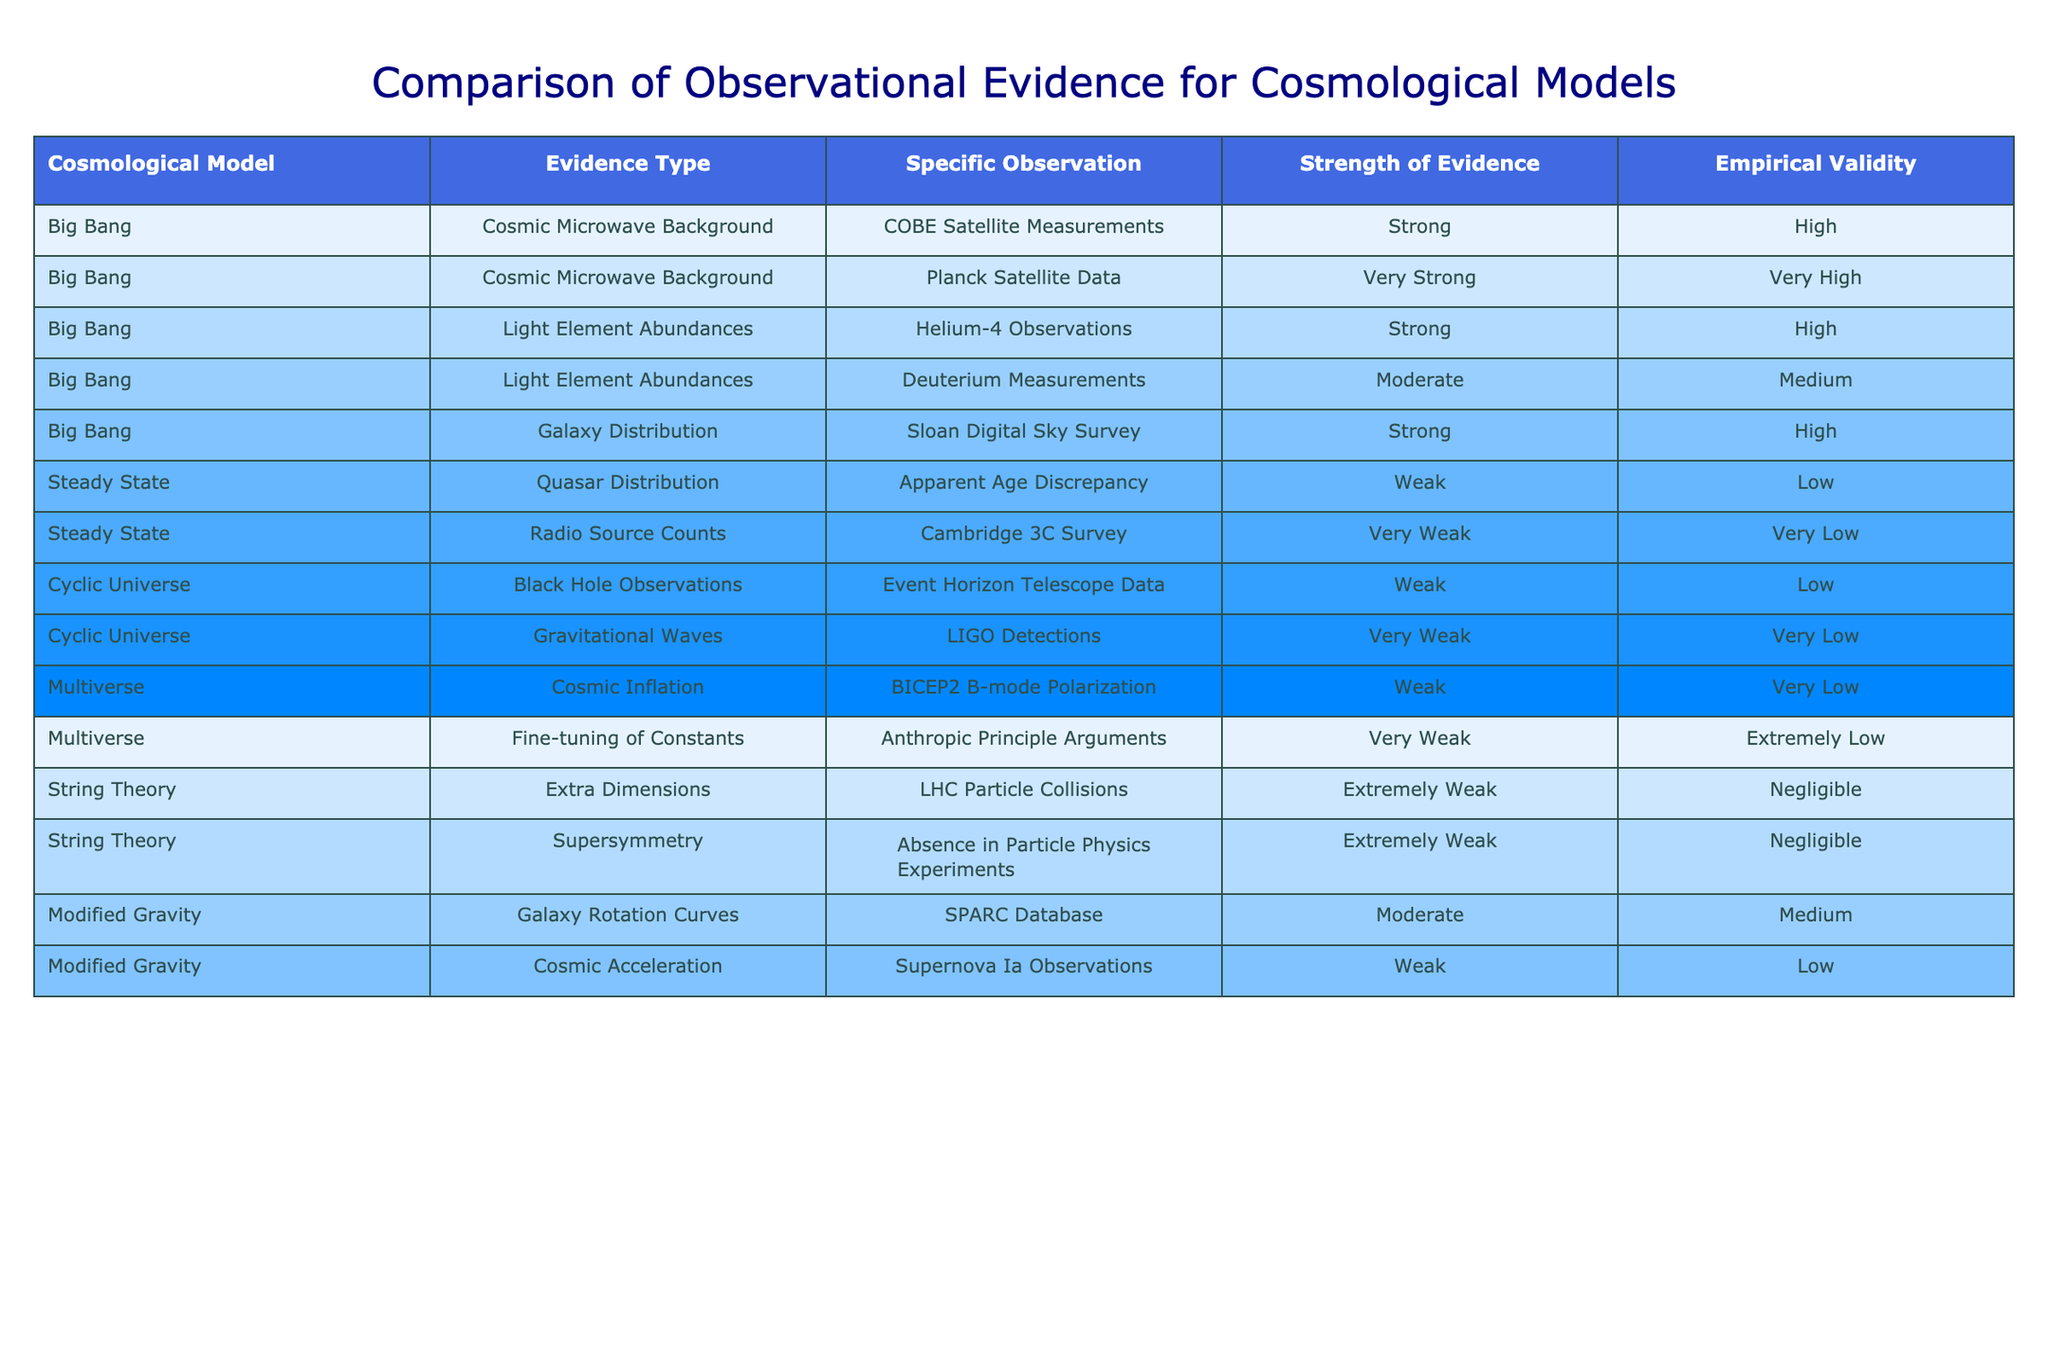What is the strength of evidence for the Planck Satellite Data? In the table, the strength of evidence for the Planck Satellite Data, which falls under the Cosmic Microwave Background type for the Big Bang model, is labeled as "Very Strong."
Answer: Very Strong Which cosmological model has the highest empirical validity? The table indicates that the Big Bang model has the highest empirical validity rating, marked as "Very High."
Answer: Very High How many types of observational evidence are listed for the Big Bang model? The Big Bang model has three types of observational evidence listed: Cosmic Microwave Background, Light Element Abundances, and Galaxy Distribution, totaling three types.
Answer: 3 What is the strength of the evidence for the understanding of Supernova Ia Observations in relation to the Modified Gravity model? The evidence strength related to Supernova Ia Observations in the Modified Gravity model is categorized as "Weak" in the table.
Answer: Weak Is there any observational evidence for the String Theory model that has a high empirical validity? The table shows that all observational evidence for the String Theory model has an empirical validity rated as "Negligible," indicating none have high empirical validity.
Answer: No Which model exhibits the weakest strength of evidence according to the table? Upon examining the table, the Multiverse model exhibits the weakest strength of evidence with observations labeled as "Very Weak" and "Extremely Weak."
Answer: Multiverse If we average the empirical validity scores for all models listed, what would that indicate? By analyzing the table, the scores are categorized as High, Medium, Low, Very Low, Negligible, and Extremely Low. With five ratings grouped into three categories with corresponding values, it shows an overall empirical validity leaning towards low.
Answer: Low What percentage of the observations for the Big Bang model are assessed as Strong or Very Strong? Counting the observations in the Big Bang model, 4 out of 5 are assessed as Strong or Very Strong, which is 80%.
Answer: 80% How does the evidence strength for Quasar Distribution in the Steady State model compare to Light Element Abundances in the Big Bang model? The Quasar Distribution in the Steady State model is rated as "Weak," while Light Element Abundances in the Big Bang model have varying strengths with the Helium-4 Observations categorized as "Strong" and Deuterium Measurements as "Moderate," showing the Big Bang flavor stronger overall.
Answer: Big Bang is stronger Are there any models that present observations with "Extremely Weak" evidence? The table indicates that both the String Theory and the Multiverse models include observations with "Extremely Weak" evidence, confirming the presence of such observations.
Answer: Yes 